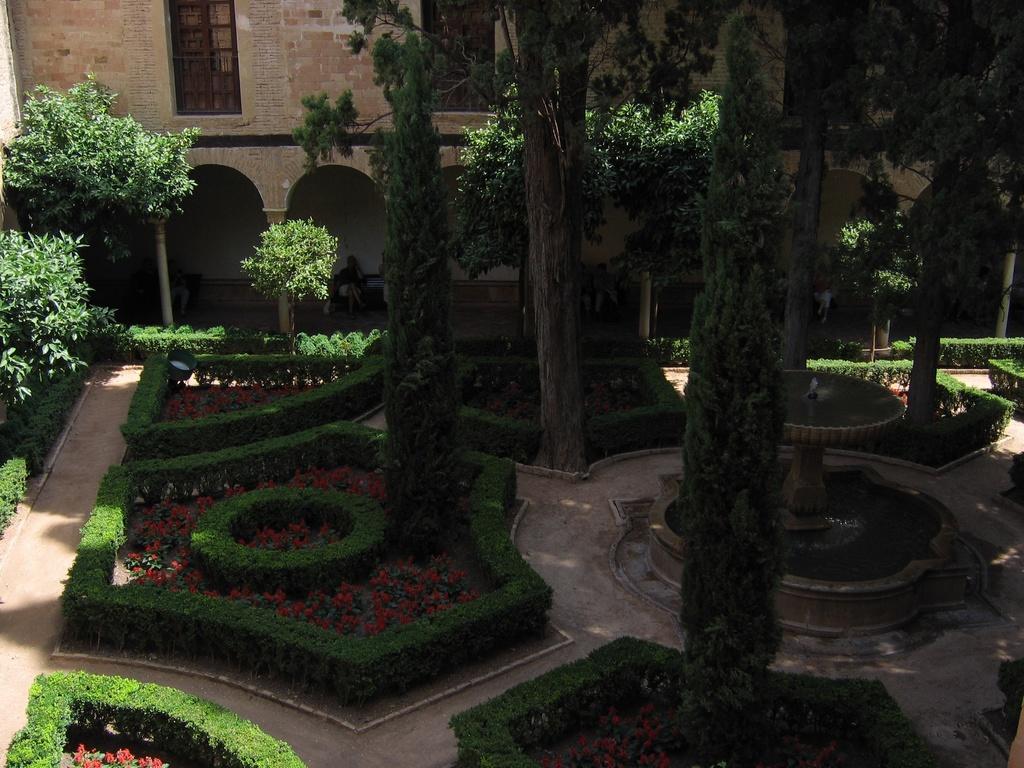Describe this image in one or two sentences. In this picture we can see trees, plants, bushes and flowers, on the right side there is a water fountain, in the background we can see a building, there is a person sitting on a bench in the middle. 